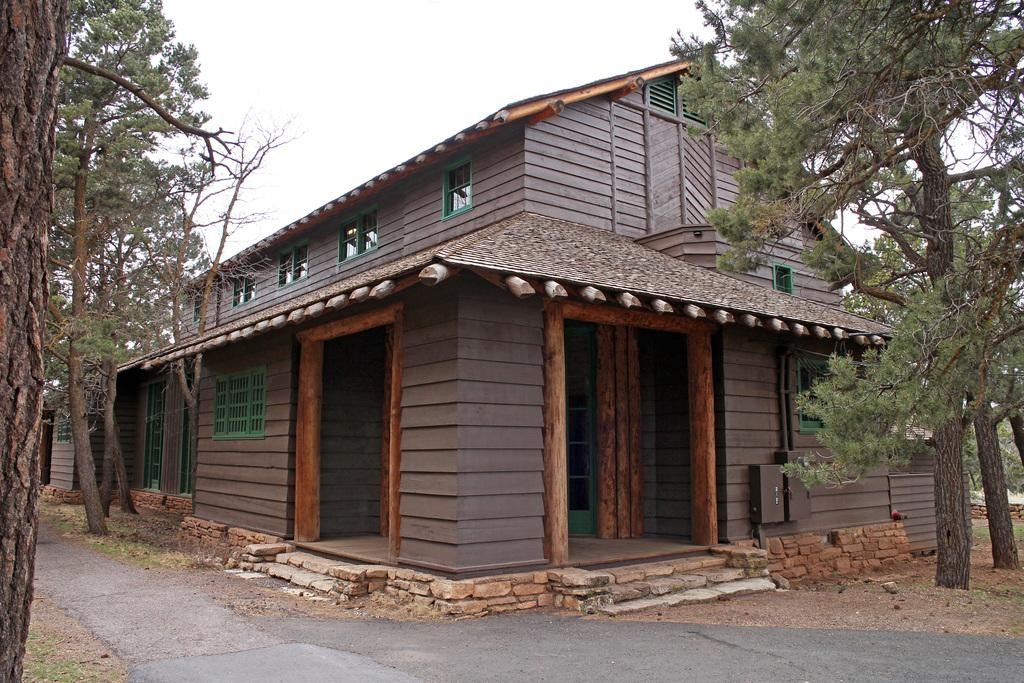What type of pathway is visible in the image? There is a road in the image. What type of structure can be seen near the road? There is a house in the image. What type of vegetation is present on both sides of the road? Trees are present on both the left and right sides of the image. What can be seen in the sky in the image? Clouds are visible in the sky. Can you tell me how many frogs are sitting on the roof of the house in the image? There are no frogs present in the image; it only features a road, a house, trees, and clouds. 